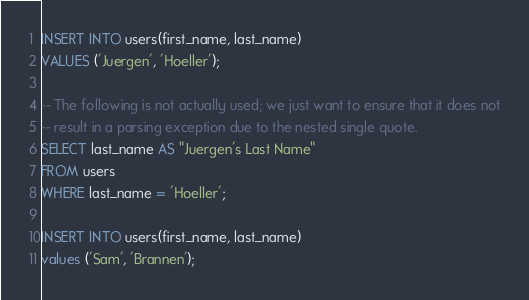<code> <loc_0><loc_0><loc_500><loc_500><_SQL_>INSERT INTO users(first_name, last_name)
VALUES ('Juergen', 'Hoeller');

-- The following is not actually used; we just want to ensure that it does not
-- result in a parsing exception due to the nested single quote.
SELECT last_name AS "Juergen's Last Name"
FROM users
WHERE last_name = 'Hoeller';

INSERT INTO users(first_name, last_name)
values ('Sam', 'Brannen');</code> 